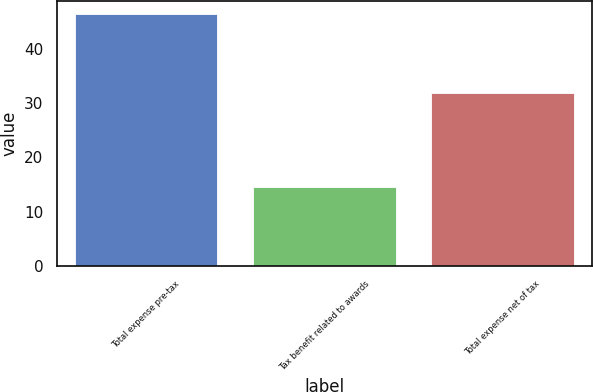Convert chart. <chart><loc_0><loc_0><loc_500><loc_500><bar_chart><fcel>Total expense pre-tax<fcel>Tax benefit related to awards<fcel>Total expense net of tax<nl><fcel>46.4<fcel>14.5<fcel>31.9<nl></chart> 